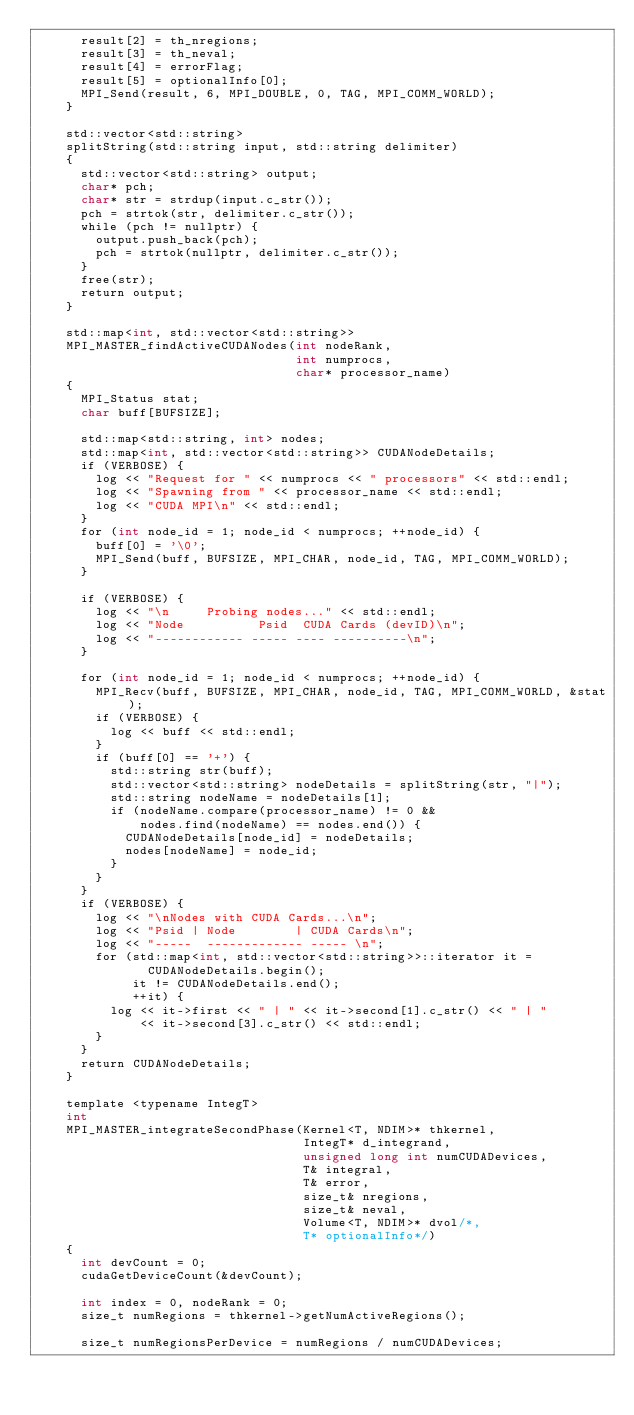Convert code to text. <code><loc_0><loc_0><loc_500><loc_500><_Cuda_>      result[2] = th_nregions;
      result[3] = th_neval;
      result[4] = errorFlag;
      result[5] = optionalInfo[0];
      MPI_Send(result, 6, MPI_DOUBLE, 0, TAG, MPI_COMM_WORLD);
    }

    std::vector<std::string>
    splitString(std::string input, std::string delimiter)
    {
      std::vector<std::string> output;
      char* pch;
      char* str = strdup(input.c_str());
      pch = strtok(str, delimiter.c_str());
      while (pch != nullptr) {
        output.push_back(pch);
        pch = strtok(nullptr, delimiter.c_str());
      }
      free(str);
      return output;
    }

    std::map<int, std::vector<std::string>>
    MPI_MASTER_findActiveCUDANodes(int nodeRank,
                                   int numprocs,
                                   char* processor_name)
    {
      MPI_Status stat;
      char buff[BUFSIZE];

      std::map<std::string, int> nodes;
      std::map<int, std::vector<std::string>> CUDANodeDetails;
      if (VERBOSE) {
        log << "Request for " << numprocs << " processors" << std::endl;
        log << "Spawning from " << processor_name << std::endl;
        log << "CUDA MPI\n" << std::endl;
      }
      for (int node_id = 1; node_id < numprocs; ++node_id) {
        buff[0] = '\0';
        MPI_Send(buff, BUFSIZE, MPI_CHAR, node_id, TAG, MPI_COMM_WORLD);
      }

      if (VERBOSE) {
        log << "\n     Probing nodes..." << std::endl;
        log << "Node          Psid  CUDA Cards (devID)\n";
        log << "------------ ----- ---- ----------\n";
      }

      for (int node_id = 1; node_id < numprocs; ++node_id) {
        MPI_Recv(buff, BUFSIZE, MPI_CHAR, node_id, TAG, MPI_COMM_WORLD, &stat);
        if (VERBOSE) {
          log << buff << std::endl;
        }
        if (buff[0] == '+') {
          std::string str(buff);
          std::vector<std::string> nodeDetails = splitString(str, "|");
          std::string nodeName = nodeDetails[1];
          if (nodeName.compare(processor_name) != 0 &&
              nodes.find(nodeName) == nodes.end()) {
            CUDANodeDetails[node_id] = nodeDetails;
            nodes[nodeName] = node_id;
          }
        }
      }
      if (VERBOSE) {
        log << "\nNodes with CUDA Cards...\n";
        log << "Psid | Node        | CUDA Cards\n";
        log << "-----  ------------- ----- \n";
        for (std::map<int, std::vector<std::string>>::iterator it =
               CUDANodeDetails.begin();
             it != CUDANodeDetails.end();
             ++it) {
          log << it->first << " | " << it->second[1].c_str() << " | "
              << it->second[3].c_str() << std::endl;
        }
      }
      return CUDANodeDetails;
    }

    template <typename IntegT>
    int
    MPI_MASTER_integrateSecondPhase(Kernel<T, NDIM>* thkernel,
                                    IntegT* d_integrand,
                                    unsigned long int numCUDADevices,
                                    T& integral,
                                    T& error,
                                    size_t& nregions,
                                    size_t& neval,
                                    Volume<T, NDIM>* dvol/*,
                                    T* optionalInfo*/)
    {
      int devCount = 0;
      cudaGetDeviceCount(&devCount);

      int index = 0, nodeRank = 0;
      size_t numRegions = thkernel->getNumActiveRegions();

      size_t numRegionsPerDevice = numRegions / numCUDADevices;</code> 